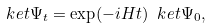Convert formula to latex. <formula><loc_0><loc_0><loc_500><loc_500>\ k e t { \Psi _ { t } } = \exp ( - i H t ) \ k e t { \Psi _ { 0 } } ,</formula> 